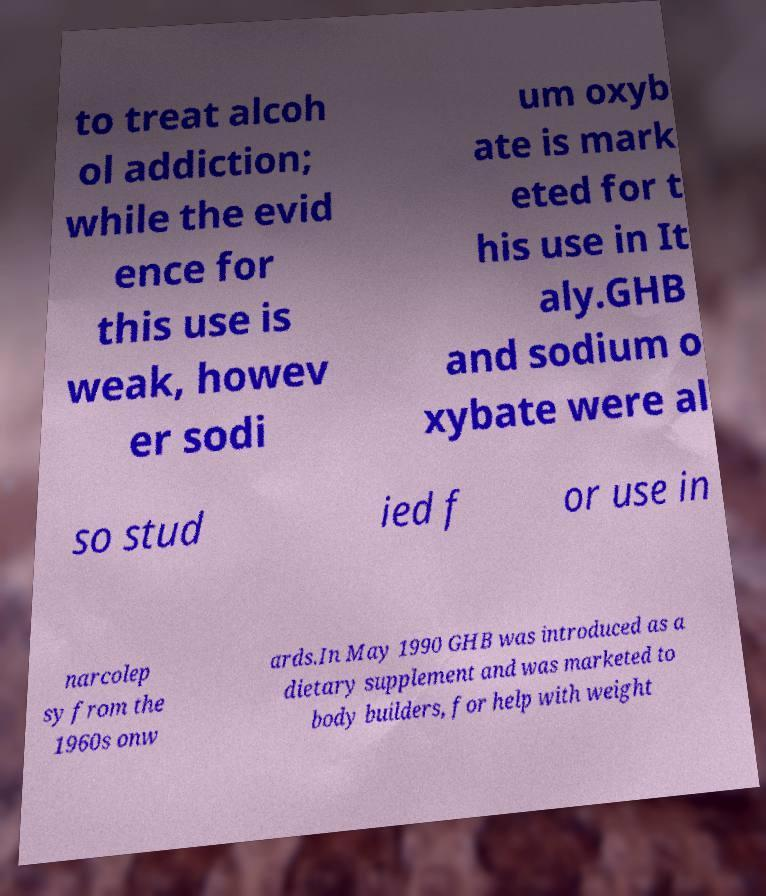Could you assist in decoding the text presented in this image and type it out clearly? to treat alcoh ol addiction; while the evid ence for this use is weak, howev er sodi um oxyb ate is mark eted for t his use in It aly.GHB and sodium o xybate were al so stud ied f or use in narcolep sy from the 1960s onw ards.In May 1990 GHB was introduced as a dietary supplement and was marketed to body builders, for help with weight 